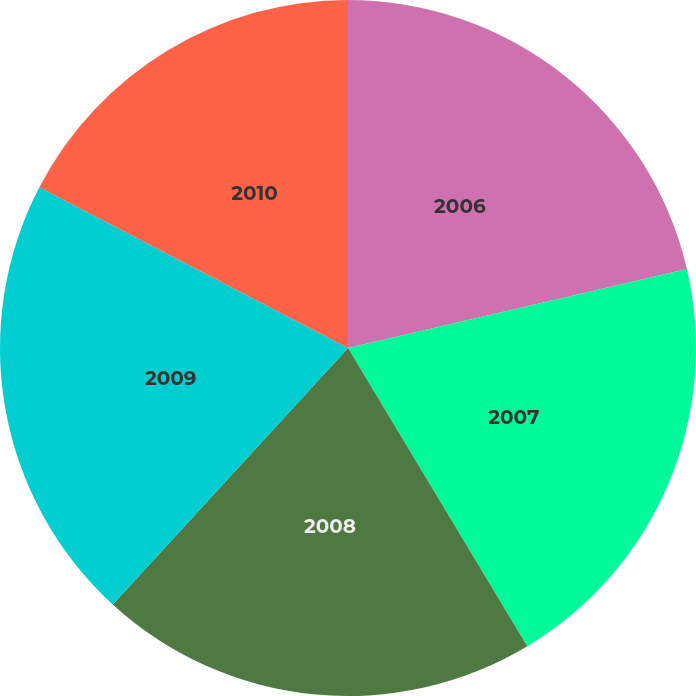Convert chart to OTSL. <chart><loc_0><loc_0><loc_500><loc_500><pie_chart><fcel>2006<fcel>2007<fcel>2008<fcel>2009<fcel>2010<nl><fcel>21.36%<fcel>20.03%<fcel>20.43%<fcel>20.83%<fcel>17.36%<nl></chart> 